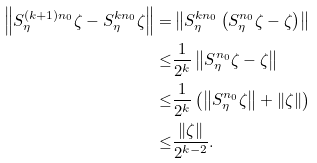<formula> <loc_0><loc_0><loc_500><loc_500>\left \| S _ { \eta } ^ { ( k + 1 ) n _ { 0 } } \zeta - S _ { \eta } ^ { k n _ { 0 } } \zeta \right \| = & \left \| S _ { \eta } ^ { k n _ { 0 } } \left ( S _ { \eta } ^ { n _ { 0 } } \zeta - \zeta \right ) \right \| \\ \leq & \frac { 1 } { 2 ^ { k } } \left \| S _ { \eta } ^ { n _ { 0 } } \zeta - \zeta \right \| \\ \leq & \frac { 1 } { 2 ^ { k } } \left ( \left \| S _ { \eta } ^ { n _ { 0 } } \zeta \right \| + \| \zeta \| \right ) \\ \leq & \frac { \| \zeta \| } { 2 ^ { k - 2 } } .</formula> 